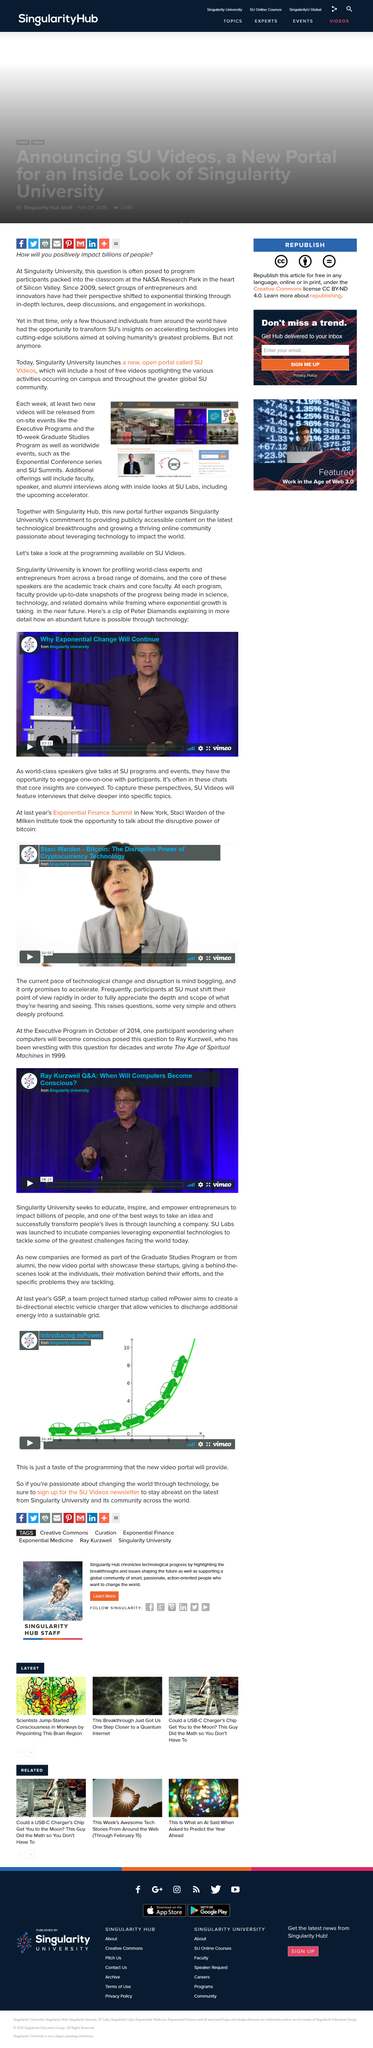Identify some key points in this picture. Yes, the Exponential Conference series are worldwide events. The video is from a university called Singularity, and I wonder what university it is from. The Exponential Finance Summit was held in New York last year. Staci Warden is featured in the video. At least two new videos will be released each week from the SU Videos portal. 